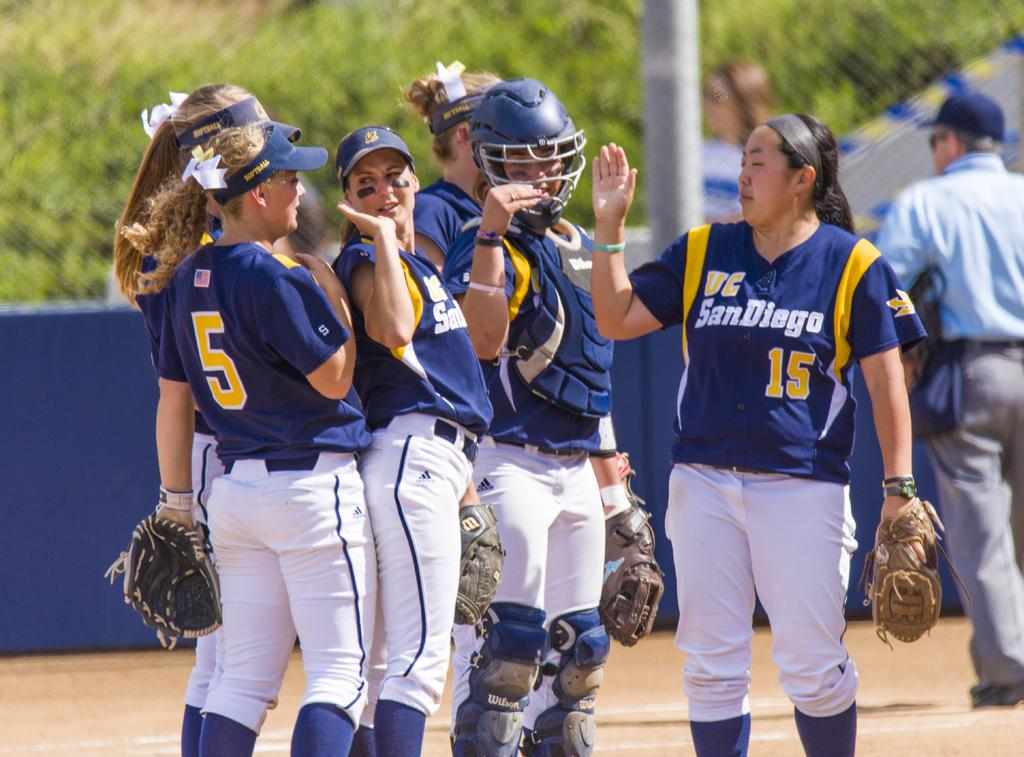<image>
Present a compact description of the photo's key features. UC San Diego is a woman's softball team. 